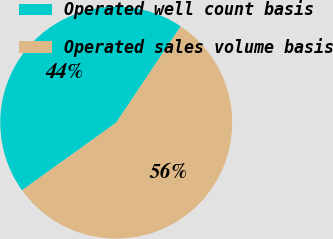<chart> <loc_0><loc_0><loc_500><loc_500><pie_chart><fcel>Operated well count basis<fcel>Operated sales volume basis<nl><fcel>44.3%<fcel>55.7%<nl></chart> 